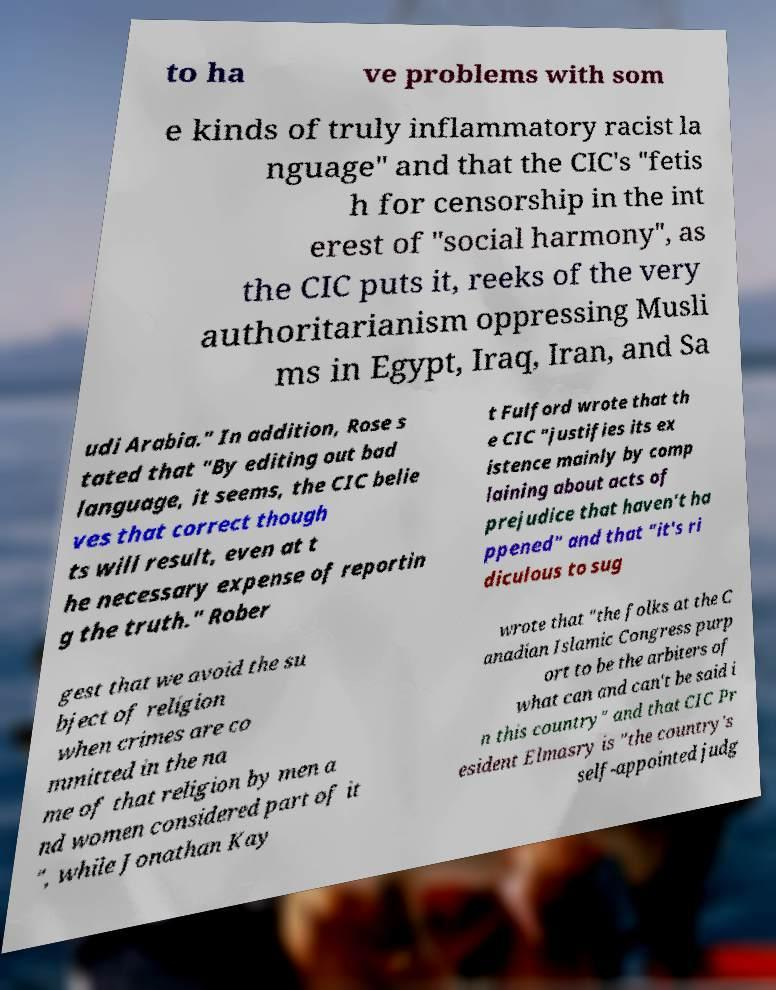What messages or text are displayed in this image? I need them in a readable, typed format. to ha ve problems with som e kinds of truly inflammatory racist la nguage" and that the CIC's "fetis h for censorship in the int erest of "social harmony", as the CIC puts it, reeks of the very authoritarianism oppressing Musli ms in Egypt, Iraq, Iran, and Sa udi Arabia." In addition, Rose s tated that "By editing out bad language, it seems, the CIC belie ves that correct though ts will result, even at t he necessary expense of reportin g the truth." Rober t Fulford wrote that th e CIC "justifies its ex istence mainly by comp laining about acts of prejudice that haven't ha ppened" and that "it's ri diculous to sug gest that we avoid the su bject of religion when crimes are co mmitted in the na me of that religion by men a nd women considered part of it ", while Jonathan Kay wrote that "the folks at the C anadian Islamic Congress purp ort to be the arbiters of what can and can't be said i n this country" and that CIC Pr esident Elmasry is "the country's self-appointed judg 